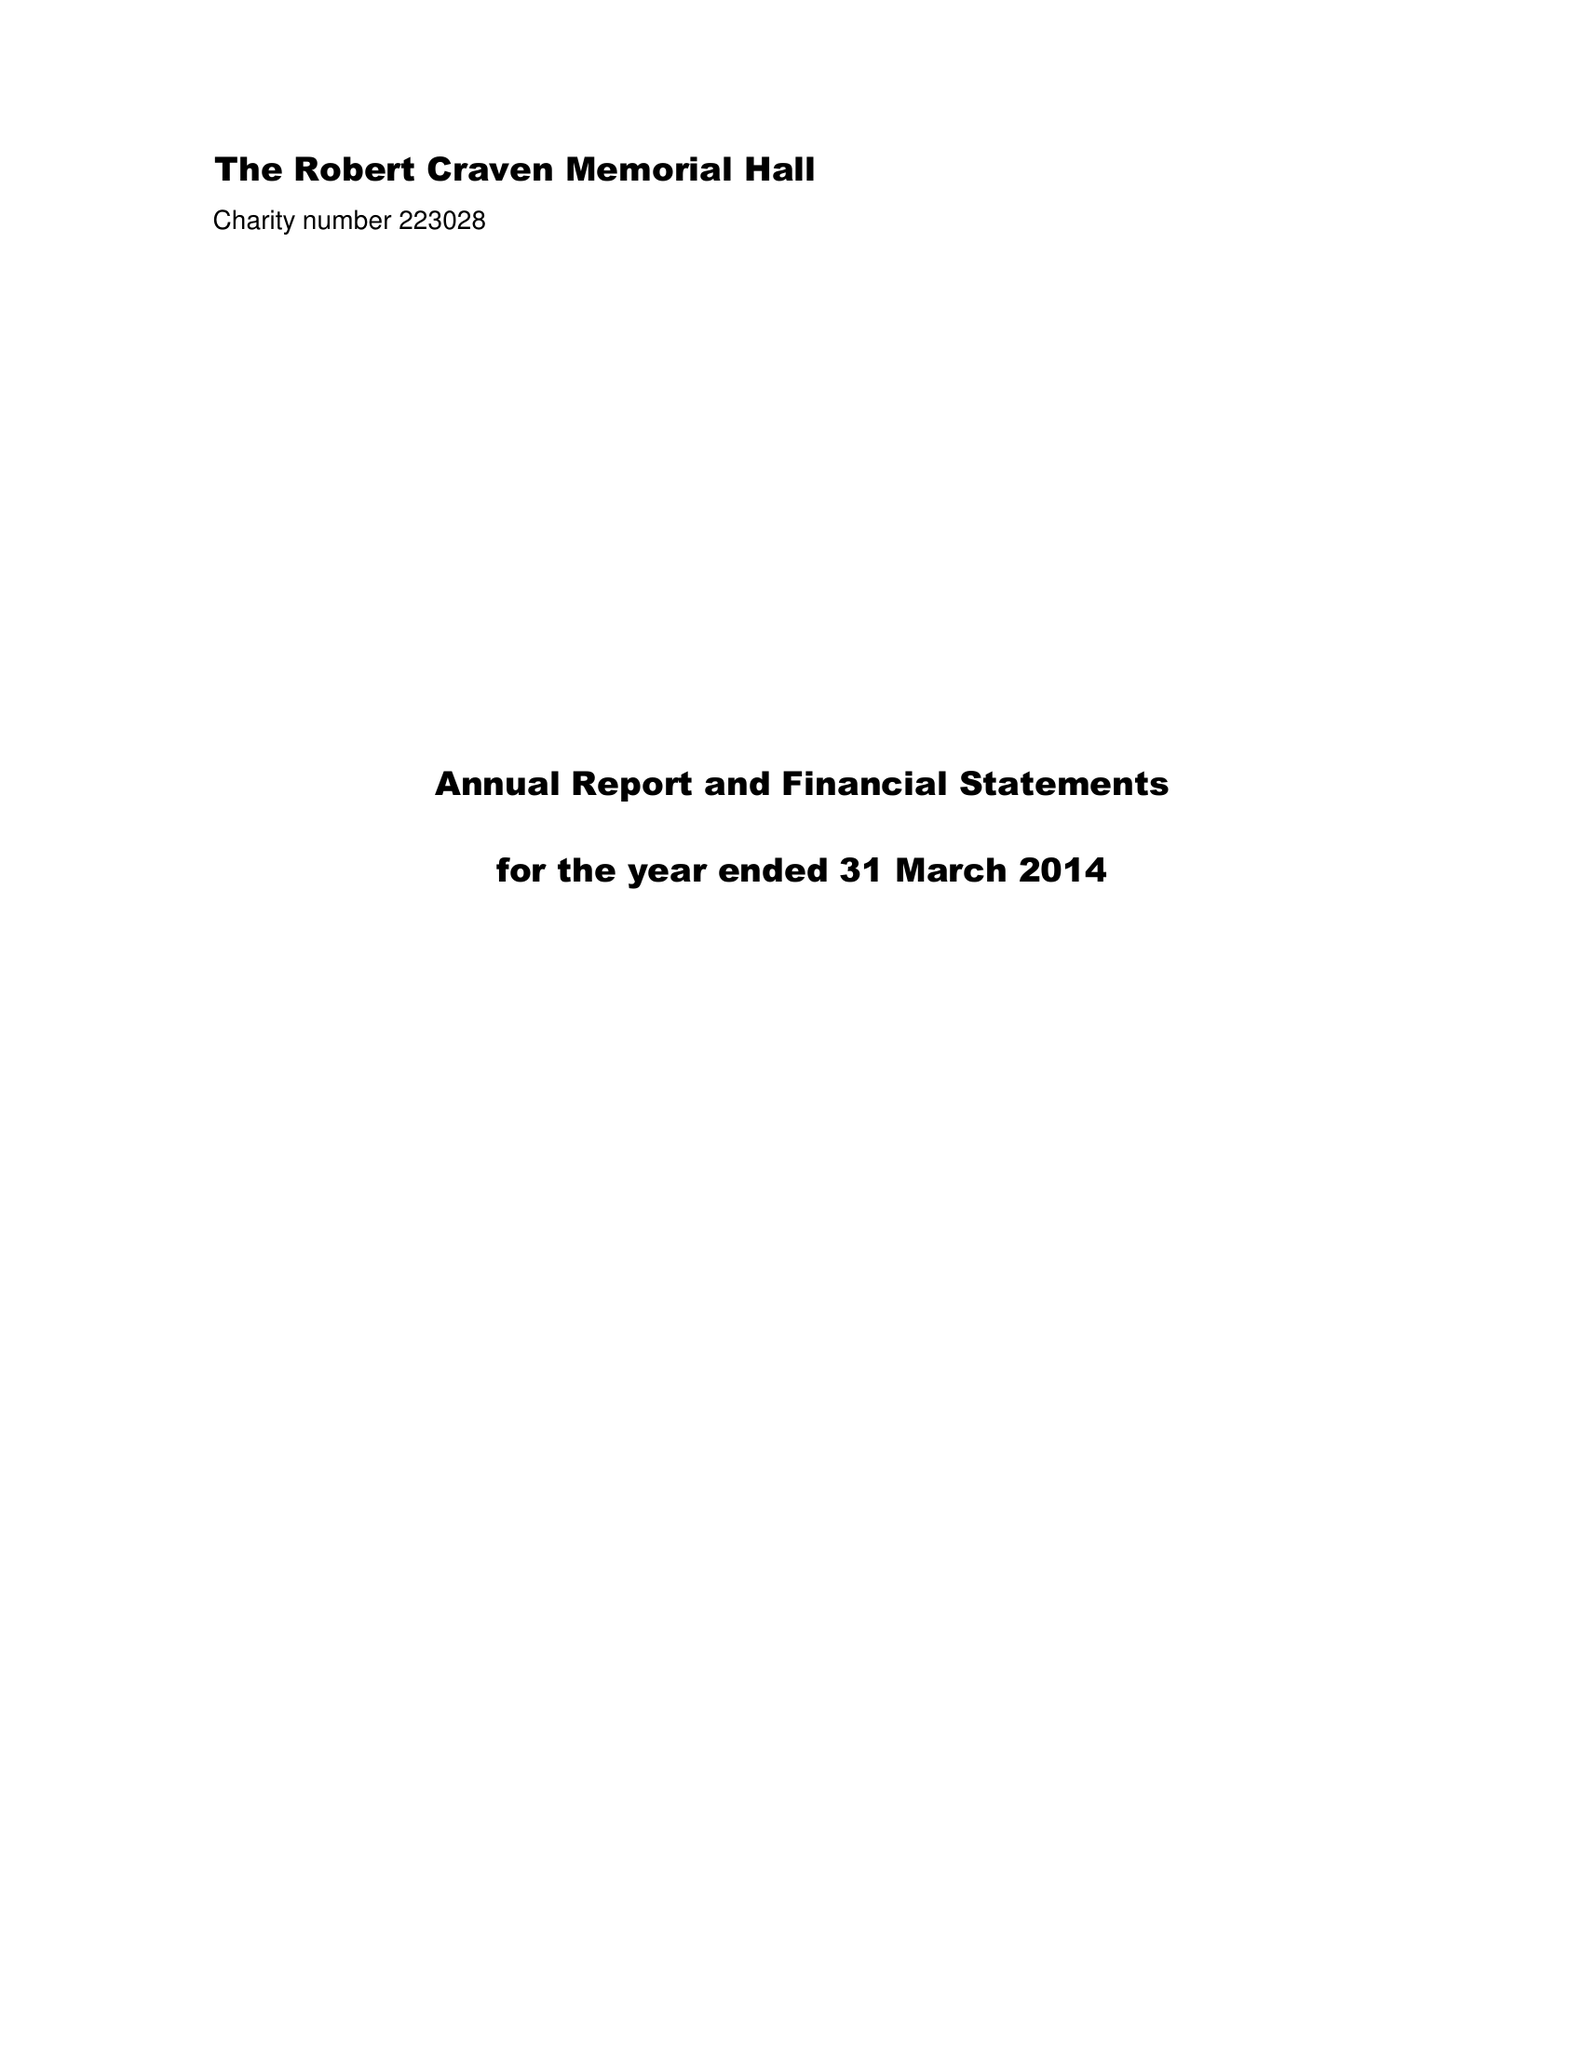What is the value for the report_date?
Answer the question using a single word or phrase. 2014-03-31 